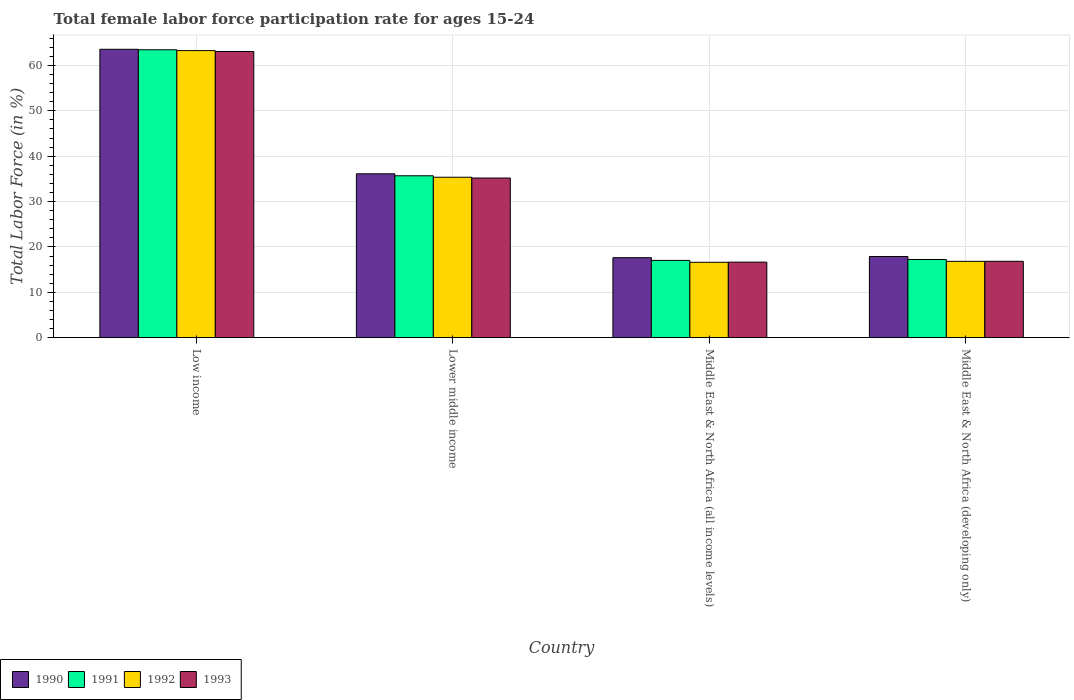How many different coloured bars are there?
Make the answer very short. 4. Are the number of bars on each tick of the X-axis equal?
Provide a short and direct response. Yes. How many bars are there on the 4th tick from the right?
Offer a terse response. 4. What is the label of the 2nd group of bars from the left?
Provide a succinct answer. Lower middle income. In how many cases, is the number of bars for a given country not equal to the number of legend labels?
Give a very brief answer. 0. What is the female labor force participation rate in 1992 in Middle East & North Africa (developing only)?
Your answer should be very brief. 16.83. Across all countries, what is the maximum female labor force participation rate in 1992?
Offer a terse response. 63.27. Across all countries, what is the minimum female labor force participation rate in 1993?
Keep it short and to the point. 16.65. In which country was the female labor force participation rate in 1993 minimum?
Make the answer very short. Middle East & North Africa (all income levels). What is the total female labor force participation rate in 1991 in the graph?
Provide a short and direct response. 133.39. What is the difference between the female labor force participation rate in 1992 in Lower middle income and that in Middle East & North Africa (all income levels)?
Make the answer very short. 18.75. What is the difference between the female labor force participation rate in 1991 in Middle East & North Africa (all income levels) and the female labor force participation rate in 1993 in Lower middle income?
Keep it short and to the point. -18.16. What is the average female labor force participation rate in 1991 per country?
Provide a succinct answer. 33.35. What is the difference between the female labor force participation rate of/in 1991 and female labor force participation rate of/in 1990 in Middle East & North Africa (developing only)?
Offer a terse response. -0.66. In how many countries, is the female labor force participation rate in 1990 greater than 64 %?
Offer a very short reply. 0. What is the ratio of the female labor force participation rate in 1991 in Lower middle income to that in Middle East & North Africa (developing only)?
Keep it short and to the point. 2.07. Is the female labor force participation rate in 1993 in Low income less than that in Middle East & North Africa (all income levels)?
Make the answer very short. No. What is the difference between the highest and the second highest female labor force participation rate in 1993?
Offer a terse response. -18.36. What is the difference between the highest and the lowest female labor force participation rate in 1990?
Offer a terse response. 45.94. Is it the case that in every country, the sum of the female labor force participation rate in 1992 and female labor force participation rate in 1990 is greater than the sum of female labor force participation rate in 1993 and female labor force participation rate in 1991?
Your answer should be very brief. No. What does the 1st bar from the left in Middle East & North Africa (all income levels) represents?
Give a very brief answer. 1990. How many bars are there?
Give a very brief answer. 16. Are all the bars in the graph horizontal?
Provide a succinct answer. No. Does the graph contain any zero values?
Offer a terse response. No. Does the graph contain grids?
Ensure brevity in your answer.  Yes. How many legend labels are there?
Offer a very short reply. 4. What is the title of the graph?
Your response must be concise. Total female labor force participation rate for ages 15-24. Does "1960" appear as one of the legend labels in the graph?
Your answer should be very brief. No. What is the label or title of the X-axis?
Make the answer very short. Country. What is the Total Labor Force (in %) in 1990 in Low income?
Offer a terse response. 63.56. What is the Total Labor Force (in %) in 1991 in Low income?
Provide a short and direct response. 63.45. What is the Total Labor Force (in %) of 1992 in Low income?
Keep it short and to the point. 63.27. What is the Total Labor Force (in %) of 1993 in Low income?
Make the answer very short. 63.08. What is the Total Labor Force (in %) in 1990 in Lower middle income?
Your answer should be compact. 36.11. What is the Total Labor Force (in %) in 1991 in Lower middle income?
Offer a terse response. 35.68. What is the Total Labor Force (in %) of 1992 in Lower middle income?
Provide a short and direct response. 35.36. What is the Total Labor Force (in %) of 1993 in Lower middle income?
Ensure brevity in your answer.  35.19. What is the Total Labor Force (in %) in 1990 in Middle East & North Africa (all income levels)?
Offer a very short reply. 17.62. What is the Total Labor Force (in %) in 1991 in Middle East & North Africa (all income levels)?
Give a very brief answer. 17.03. What is the Total Labor Force (in %) of 1992 in Middle East & North Africa (all income levels)?
Your answer should be very brief. 16.61. What is the Total Labor Force (in %) in 1993 in Middle East & North Africa (all income levels)?
Give a very brief answer. 16.65. What is the Total Labor Force (in %) in 1990 in Middle East & North Africa (developing only)?
Your answer should be compact. 17.89. What is the Total Labor Force (in %) in 1991 in Middle East & North Africa (developing only)?
Offer a very short reply. 17.23. What is the Total Labor Force (in %) of 1992 in Middle East & North Africa (developing only)?
Give a very brief answer. 16.83. What is the Total Labor Force (in %) of 1993 in Middle East & North Africa (developing only)?
Offer a very short reply. 16.83. Across all countries, what is the maximum Total Labor Force (in %) of 1990?
Ensure brevity in your answer.  63.56. Across all countries, what is the maximum Total Labor Force (in %) in 1991?
Provide a short and direct response. 63.45. Across all countries, what is the maximum Total Labor Force (in %) in 1992?
Ensure brevity in your answer.  63.27. Across all countries, what is the maximum Total Labor Force (in %) in 1993?
Your response must be concise. 63.08. Across all countries, what is the minimum Total Labor Force (in %) in 1990?
Your answer should be very brief. 17.62. Across all countries, what is the minimum Total Labor Force (in %) of 1991?
Keep it short and to the point. 17.03. Across all countries, what is the minimum Total Labor Force (in %) in 1992?
Give a very brief answer. 16.61. Across all countries, what is the minimum Total Labor Force (in %) in 1993?
Offer a terse response. 16.65. What is the total Total Labor Force (in %) of 1990 in the graph?
Your answer should be compact. 135.19. What is the total Total Labor Force (in %) of 1991 in the graph?
Give a very brief answer. 133.39. What is the total Total Labor Force (in %) of 1992 in the graph?
Make the answer very short. 132.07. What is the total Total Labor Force (in %) of 1993 in the graph?
Offer a very short reply. 131.74. What is the difference between the Total Labor Force (in %) of 1990 in Low income and that in Lower middle income?
Your answer should be compact. 27.45. What is the difference between the Total Labor Force (in %) of 1991 in Low income and that in Lower middle income?
Offer a terse response. 27.77. What is the difference between the Total Labor Force (in %) of 1992 in Low income and that in Lower middle income?
Offer a terse response. 27.91. What is the difference between the Total Labor Force (in %) in 1993 in Low income and that in Lower middle income?
Keep it short and to the point. 27.89. What is the difference between the Total Labor Force (in %) of 1990 in Low income and that in Middle East & North Africa (all income levels)?
Provide a succinct answer. 45.94. What is the difference between the Total Labor Force (in %) of 1991 in Low income and that in Middle East & North Africa (all income levels)?
Give a very brief answer. 46.42. What is the difference between the Total Labor Force (in %) of 1992 in Low income and that in Middle East & North Africa (all income levels)?
Provide a succinct answer. 46.66. What is the difference between the Total Labor Force (in %) of 1993 in Low income and that in Middle East & North Africa (all income levels)?
Make the answer very short. 46.43. What is the difference between the Total Labor Force (in %) in 1990 in Low income and that in Middle East & North Africa (developing only)?
Your answer should be compact. 45.67. What is the difference between the Total Labor Force (in %) in 1991 in Low income and that in Middle East & North Africa (developing only)?
Offer a terse response. 46.22. What is the difference between the Total Labor Force (in %) in 1992 in Low income and that in Middle East & North Africa (developing only)?
Provide a short and direct response. 46.45. What is the difference between the Total Labor Force (in %) of 1993 in Low income and that in Middle East & North Africa (developing only)?
Your answer should be compact. 46.25. What is the difference between the Total Labor Force (in %) of 1990 in Lower middle income and that in Middle East & North Africa (all income levels)?
Your response must be concise. 18.49. What is the difference between the Total Labor Force (in %) of 1991 in Lower middle income and that in Middle East & North Africa (all income levels)?
Keep it short and to the point. 18.65. What is the difference between the Total Labor Force (in %) of 1992 in Lower middle income and that in Middle East & North Africa (all income levels)?
Give a very brief answer. 18.75. What is the difference between the Total Labor Force (in %) of 1993 in Lower middle income and that in Middle East & North Africa (all income levels)?
Give a very brief answer. 18.54. What is the difference between the Total Labor Force (in %) in 1990 in Lower middle income and that in Middle East & North Africa (developing only)?
Make the answer very short. 18.22. What is the difference between the Total Labor Force (in %) of 1991 in Lower middle income and that in Middle East & North Africa (developing only)?
Ensure brevity in your answer.  18.46. What is the difference between the Total Labor Force (in %) of 1992 in Lower middle income and that in Middle East & North Africa (developing only)?
Keep it short and to the point. 18.53. What is the difference between the Total Labor Force (in %) in 1993 in Lower middle income and that in Middle East & North Africa (developing only)?
Ensure brevity in your answer.  18.36. What is the difference between the Total Labor Force (in %) of 1990 in Middle East & North Africa (all income levels) and that in Middle East & North Africa (developing only)?
Give a very brief answer. -0.26. What is the difference between the Total Labor Force (in %) of 1991 in Middle East & North Africa (all income levels) and that in Middle East & North Africa (developing only)?
Your answer should be compact. -0.2. What is the difference between the Total Labor Force (in %) in 1992 in Middle East & North Africa (all income levels) and that in Middle East & North Africa (developing only)?
Keep it short and to the point. -0.22. What is the difference between the Total Labor Force (in %) of 1993 in Middle East & North Africa (all income levels) and that in Middle East & North Africa (developing only)?
Your answer should be very brief. -0.18. What is the difference between the Total Labor Force (in %) in 1990 in Low income and the Total Labor Force (in %) in 1991 in Lower middle income?
Offer a very short reply. 27.88. What is the difference between the Total Labor Force (in %) of 1990 in Low income and the Total Labor Force (in %) of 1992 in Lower middle income?
Give a very brief answer. 28.2. What is the difference between the Total Labor Force (in %) of 1990 in Low income and the Total Labor Force (in %) of 1993 in Lower middle income?
Ensure brevity in your answer.  28.37. What is the difference between the Total Labor Force (in %) in 1991 in Low income and the Total Labor Force (in %) in 1992 in Lower middle income?
Keep it short and to the point. 28.09. What is the difference between the Total Labor Force (in %) of 1991 in Low income and the Total Labor Force (in %) of 1993 in Lower middle income?
Keep it short and to the point. 28.26. What is the difference between the Total Labor Force (in %) in 1992 in Low income and the Total Labor Force (in %) in 1993 in Lower middle income?
Give a very brief answer. 28.09. What is the difference between the Total Labor Force (in %) of 1990 in Low income and the Total Labor Force (in %) of 1991 in Middle East & North Africa (all income levels)?
Your answer should be compact. 46.53. What is the difference between the Total Labor Force (in %) of 1990 in Low income and the Total Labor Force (in %) of 1992 in Middle East & North Africa (all income levels)?
Provide a short and direct response. 46.95. What is the difference between the Total Labor Force (in %) of 1990 in Low income and the Total Labor Force (in %) of 1993 in Middle East & North Africa (all income levels)?
Provide a succinct answer. 46.92. What is the difference between the Total Labor Force (in %) in 1991 in Low income and the Total Labor Force (in %) in 1992 in Middle East & North Africa (all income levels)?
Your response must be concise. 46.84. What is the difference between the Total Labor Force (in %) of 1991 in Low income and the Total Labor Force (in %) of 1993 in Middle East & North Africa (all income levels)?
Give a very brief answer. 46.8. What is the difference between the Total Labor Force (in %) of 1992 in Low income and the Total Labor Force (in %) of 1993 in Middle East & North Africa (all income levels)?
Your response must be concise. 46.63. What is the difference between the Total Labor Force (in %) of 1990 in Low income and the Total Labor Force (in %) of 1991 in Middle East & North Africa (developing only)?
Ensure brevity in your answer.  46.33. What is the difference between the Total Labor Force (in %) in 1990 in Low income and the Total Labor Force (in %) in 1992 in Middle East & North Africa (developing only)?
Your response must be concise. 46.74. What is the difference between the Total Labor Force (in %) in 1990 in Low income and the Total Labor Force (in %) in 1993 in Middle East & North Africa (developing only)?
Offer a very short reply. 46.73. What is the difference between the Total Labor Force (in %) in 1991 in Low income and the Total Labor Force (in %) in 1992 in Middle East & North Africa (developing only)?
Keep it short and to the point. 46.63. What is the difference between the Total Labor Force (in %) of 1991 in Low income and the Total Labor Force (in %) of 1993 in Middle East & North Africa (developing only)?
Make the answer very short. 46.62. What is the difference between the Total Labor Force (in %) in 1992 in Low income and the Total Labor Force (in %) in 1993 in Middle East & North Africa (developing only)?
Give a very brief answer. 46.44. What is the difference between the Total Labor Force (in %) in 1990 in Lower middle income and the Total Labor Force (in %) in 1991 in Middle East & North Africa (all income levels)?
Give a very brief answer. 19.08. What is the difference between the Total Labor Force (in %) of 1990 in Lower middle income and the Total Labor Force (in %) of 1992 in Middle East & North Africa (all income levels)?
Provide a succinct answer. 19.5. What is the difference between the Total Labor Force (in %) in 1990 in Lower middle income and the Total Labor Force (in %) in 1993 in Middle East & North Africa (all income levels)?
Make the answer very short. 19.47. What is the difference between the Total Labor Force (in %) of 1991 in Lower middle income and the Total Labor Force (in %) of 1992 in Middle East & North Africa (all income levels)?
Give a very brief answer. 19.08. What is the difference between the Total Labor Force (in %) of 1991 in Lower middle income and the Total Labor Force (in %) of 1993 in Middle East & North Africa (all income levels)?
Give a very brief answer. 19.04. What is the difference between the Total Labor Force (in %) of 1992 in Lower middle income and the Total Labor Force (in %) of 1993 in Middle East & North Africa (all income levels)?
Ensure brevity in your answer.  18.71. What is the difference between the Total Labor Force (in %) in 1990 in Lower middle income and the Total Labor Force (in %) in 1991 in Middle East & North Africa (developing only)?
Keep it short and to the point. 18.88. What is the difference between the Total Labor Force (in %) in 1990 in Lower middle income and the Total Labor Force (in %) in 1992 in Middle East & North Africa (developing only)?
Offer a very short reply. 19.29. What is the difference between the Total Labor Force (in %) of 1990 in Lower middle income and the Total Labor Force (in %) of 1993 in Middle East & North Africa (developing only)?
Offer a very short reply. 19.28. What is the difference between the Total Labor Force (in %) in 1991 in Lower middle income and the Total Labor Force (in %) in 1992 in Middle East & North Africa (developing only)?
Your answer should be very brief. 18.86. What is the difference between the Total Labor Force (in %) of 1991 in Lower middle income and the Total Labor Force (in %) of 1993 in Middle East & North Africa (developing only)?
Make the answer very short. 18.85. What is the difference between the Total Labor Force (in %) of 1992 in Lower middle income and the Total Labor Force (in %) of 1993 in Middle East & North Africa (developing only)?
Provide a short and direct response. 18.53. What is the difference between the Total Labor Force (in %) in 1990 in Middle East & North Africa (all income levels) and the Total Labor Force (in %) in 1991 in Middle East & North Africa (developing only)?
Offer a terse response. 0.4. What is the difference between the Total Labor Force (in %) of 1990 in Middle East & North Africa (all income levels) and the Total Labor Force (in %) of 1992 in Middle East & North Africa (developing only)?
Ensure brevity in your answer.  0.8. What is the difference between the Total Labor Force (in %) in 1990 in Middle East & North Africa (all income levels) and the Total Labor Force (in %) in 1993 in Middle East & North Africa (developing only)?
Offer a very short reply. 0.79. What is the difference between the Total Labor Force (in %) of 1991 in Middle East & North Africa (all income levels) and the Total Labor Force (in %) of 1992 in Middle East & North Africa (developing only)?
Your response must be concise. 0.2. What is the difference between the Total Labor Force (in %) in 1991 in Middle East & North Africa (all income levels) and the Total Labor Force (in %) in 1993 in Middle East & North Africa (developing only)?
Provide a short and direct response. 0.2. What is the difference between the Total Labor Force (in %) of 1992 in Middle East & North Africa (all income levels) and the Total Labor Force (in %) of 1993 in Middle East & North Africa (developing only)?
Provide a short and direct response. -0.22. What is the average Total Labor Force (in %) of 1990 per country?
Provide a succinct answer. 33.8. What is the average Total Labor Force (in %) in 1991 per country?
Provide a succinct answer. 33.35. What is the average Total Labor Force (in %) of 1992 per country?
Offer a terse response. 33.02. What is the average Total Labor Force (in %) of 1993 per country?
Offer a very short reply. 32.94. What is the difference between the Total Labor Force (in %) of 1990 and Total Labor Force (in %) of 1991 in Low income?
Give a very brief answer. 0.11. What is the difference between the Total Labor Force (in %) in 1990 and Total Labor Force (in %) in 1992 in Low income?
Provide a short and direct response. 0.29. What is the difference between the Total Labor Force (in %) in 1990 and Total Labor Force (in %) in 1993 in Low income?
Your response must be concise. 0.48. What is the difference between the Total Labor Force (in %) in 1991 and Total Labor Force (in %) in 1992 in Low income?
Offer a terse response. 0.18. What is the difference between the Total Labor Force (in %) of 1991 and Total Labor Force (in %) of 1993 in Low income?
Give a very brief answer. 0.37. What is the difference between the Total Labor Force (in %) of 1992 and Total Labor Force (in %) of 1993 in Low income?
Keep it short and to the point. 0.2. What is the difference between the Total Labor Force (in %) of 1990 and Total Labor Force (in %) of 1991 in Lower middle income?
Make the answer very short. 0.43. What is the difference between the Total Labor Force (in %) in 1990 and Total Labor Force (in %) in 1992 in Lower middle income?
Keep it short and to the point. 0.75. What is the difference between the Total Labor Force (in %) of 1990 and Total Labor Force (in %) of 1993 in Lower middle income?
Give a very brief answer. 0.93. What is the difference between the Total Labor Force (in %) of 1991 and Total Labor Force (in %) of 1992 in Lower middle income?
Your answer should be compact. 0.32. What is the difference between the Total Labor Force (in %) in 1991 and Total Labor Force (in %) in 1993 in Lower middle income?
Provide a short and direct response. 0.5. What is the difference between the Total Labor Force (in %) in 1992 and Total Labor Force (in %) in 1993 in Lower middle income?
Make the answer very short. 0.17. What is the difference between the Total Labor Force (in %) in 1990 and Total Labor Force (in %) in 1991 in Middle East & North Africa (all income levels)?
Your response must be concise. 0.6. What is the difference between the Total Labor Force (in %) of 1990 and Total Labor Force (in %) of 1992 in Middle East & North Africa (all income levels)?
Provide a short and direct response. 1.02. What is the difference between the Total Labor Force (in %) of 1990 and Total Labor Force (in %) of 1993 in Middle East & North Africa (all income levels)?
Ensure brevity in your answer.  0.98. What is the difference between the Total Labor Force (in %) of 1991 and Total Labor Force (in %) of 1992 in Middle East & North Africa (all income levels)?
Provide a succinct answer. 0.42. What is the difference between the Total Labor Force (in %) of 1991 and Total Labor Force (in %) of 1993 in Middle East & North Africa (all income levels)?
Offer a very short reply. 0.38. What is the difference between the Total Labor Force (in %) in 1992 and Total Labor Force (in %) in 1993 in Middle East & North Africa (all income levels)?
Offer a very short reply. -0.04. What is the difference between the Total Labor Force (in %) in 1990 and Total Labor Force (in %) in 1991 in Middle East & North Africa (developing only)?
Offer a very short reply. 0.66. What is the difference between the Total Labor Force (in %) in 1990 and Total Labor Force (in %) in 1992 in Middle East & North Africa (developing only)?
Offer a very short reply. 1.06. What is the difference between the Total Labor Force (in %) in 1990 and Total Labor Force (in %) in 1993 in Middle East & North Africa (developing only)?
Make the answer very short. 1.06. What is the difference between the Total Labor Force (in %) in 1991 and Total Labor Force (in %) in 1992 in Middle East & North Africa (developing only)?
Make the answer very short. 0.4. What is the difference between the Total Labor Force (in %) of 1991 and Total Labor Force (in %) of 1993 in Middle East & North Africa (developing only)?
Give a very brief answer. 0.4. What is the difference between the Total Labor Force (in %) in 1992 and Total Labor Force (in %) in 1993 in Middle East & North Africa (developing only)?
Your response must be concise. -0.01. What is the ratio of the Total Labor Force (in %) in 1990 in Low income to that in Lower middle income?
Ensure brevity in your answer.  1.76. What is the ratio of the Total Labor Force (in %) in 1991 in Low income to that in Lower middle income?
Provide a short and direct response. 1.78. What is the ratio of the Total Labor Force (in %) of 1992 in Low income to that in Lower middle income?
Provide a succinct answer. 1.79. What is the ratio of the Total Labor Force (in %) of 1993 in Low income to that in Lower middle income?
Ensure brevity in your answer.  1.79. What is the ratio of the Total Labor Force (in %) of 1990 in Low income to that in Middle East & North Africa (all income levels)?
Offer a very short reply. 3.61. What is the ratio of the Total Labor Force (in %) of 1991 in Low income to that in Middle East & North Africa (all income levels)?
Your answer should be very brief. 3.73. What is the ratio of the Total Labor Force (in %) in 1992 in Low income to that in Middle East & North Africa (all income levels)?
Your response must be concise. 3.81. What is the ratio of the Total Labor Force (in %) of 1993 in Low income to that in Middle East & North Africa (all income levels)?
Ensure brevity in your answer.  3.79. What is the ratio of the Total Labor Force (in %) of 1990 in Low income to that in Middle East & North Africa (developing only)?
Your answer should be compact. 3.55. What is the ratio of the Total Labor Force (in %) of 1991 in Low income to that in Middle East & North Africa (developing only)?
Offer a terse response. 3.68. What is the ratio of the Total Labor Force (in %) in 1992 in Low income to that in Middle East & North Africa (developing only)?
Your answer should be compact. 3.76. What is the ratio of the Total Labor Force (in %) in 1993 in Low income to that in Middle East & North Africa (developing only)?
Provide a short and direct response. 3.75. What is the ratio of the Total Labor Force (in %) in 1990 in Lower middle income to that in Middle East & North Africa (all income levels)?
Ensure brevity in your answer.  2.05. What is the ratio of the Total Labor Force (in %) of 1991 in Lower middle income to that in Middle East & North Africa (all income levels)?
Provide a short and direct response. 2.1. What is the ratio of the Total Labor Force (in %) of 1992 in Lower middle income to that in Middle East & North Africa (all income levels)?
Offer a very short reply. 2.13. What is the ratio of the Total Labor Force (in %) in 1993 in Lower middle income to that in Middle East & North Africa (all income levels)?
Your answer should be very brief. 2.11. What is the ratio of the Total Labor Force (in %) of 1990 in Lower middle income to that in Middle East & North Africa (developing only)?
Provide a short and direct response. 2.02. What is the ratio of the Total Labor Force (in %) in 1991 in Lower middle income to that in Middle East & North Africa (developing only)?
Offer a terse response. 2.07. What is the ratio of the Total Labor Force (in %) of 1992 in Lower middle income to that in Middle East & North Africa (developing only)?
Keep it short and to the point. 2.1. What is the ratio of the Total Labor Force (in %) of 1993 in Lower middle income to that in Middle East & North Africa (developing only)?
Make the answer very short. 2.09. What is the ratio of the Total Labor Force (in %) in 1990 in Middle East & North Africa (all income levels) to that in Middle East & North Africa (developing only)?
Keep it short and to the point. 0.99. What is the ratio of the Total Labor Force (in %) in 1991 in Middle East & North Africa (all income levels) to that in Middle East & North Africa (developing only)?
Provide a short and direct response. 0.99. What is the ratio of the Total Labor Force (in %) in 1992 in Middle East & North Africa (all income levels) to that in Middle East & North Africa (developing only)?
Give a very brief answer. 0.99. What is the ratio of the Total Labor Force (in %) of 1993 in Middle East & North Africa (all income levels) to that in Middle East & North Africa (developing only)?
Offer a very short reply. 0.99. What is the difference between the highest and the second highest Total Labor Force (in %) in 1990?
Your response must be concise. 27.45. What is the difference between the highest and the second highest Total Labor Force (in %) of 1991?
Keep it short and to the point. 27.77. What is the difference between the highest and the second highest Total Labor Force (in %) in 1992?
Your answer should be very brief. 27.91. What is the difference between the highest and the second highest Total Labor Force (in %) in 1993?
Ensure brevity in your answer.  27.89. What is the difference between the highest and the lowest Total Labor Force (in %) of 1990?
Ensure brevity in your answer.  45.94. What is the difference between the highest and the lowest Total Labor Force (in %) of 1991?
Provide a short and direct response. 46.42. What is the difference between the highest and the lowest Total Labor Force (in %) of 1992?
Ensure brevity in your answer.  46.66. What is the difference between the highest and the lowest Total Labor Force (in %) of 1993?
Give a very brief answer. 46.43. 